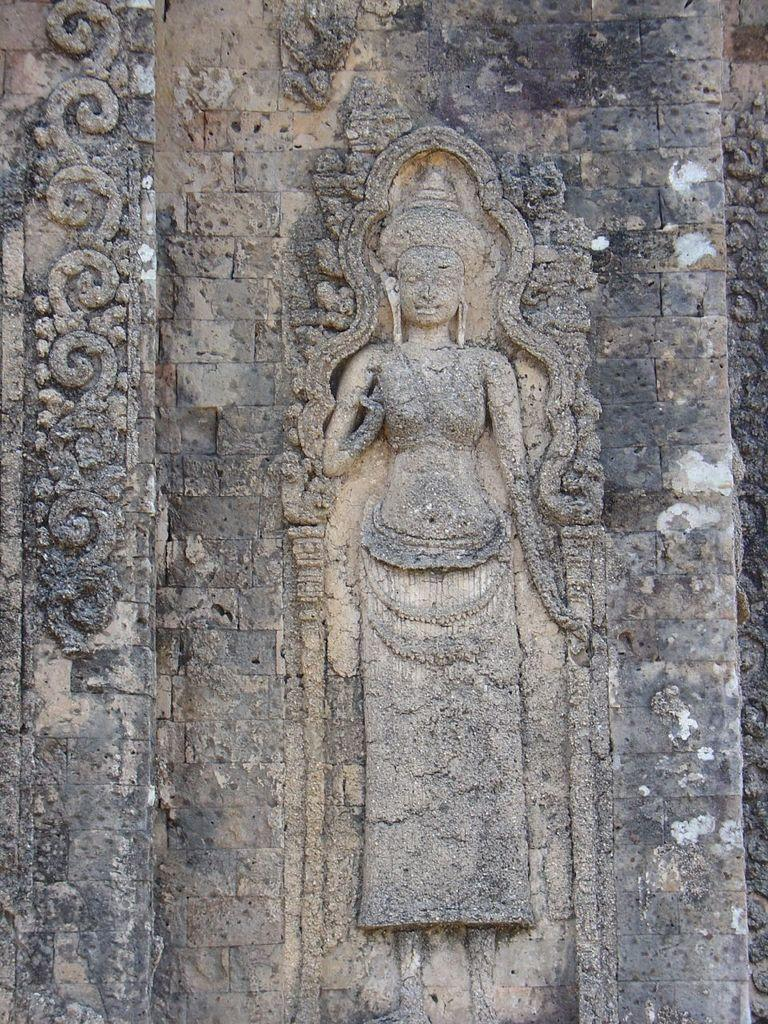What can be seen on the wall in the image? There are carvings on the wall in the image. How often do the carvings change on the wall in the image? The frequency of change for the carvings cannot be determined from the image, as there is no information provided about the carvings' permanence or the time frame in which they were created. 